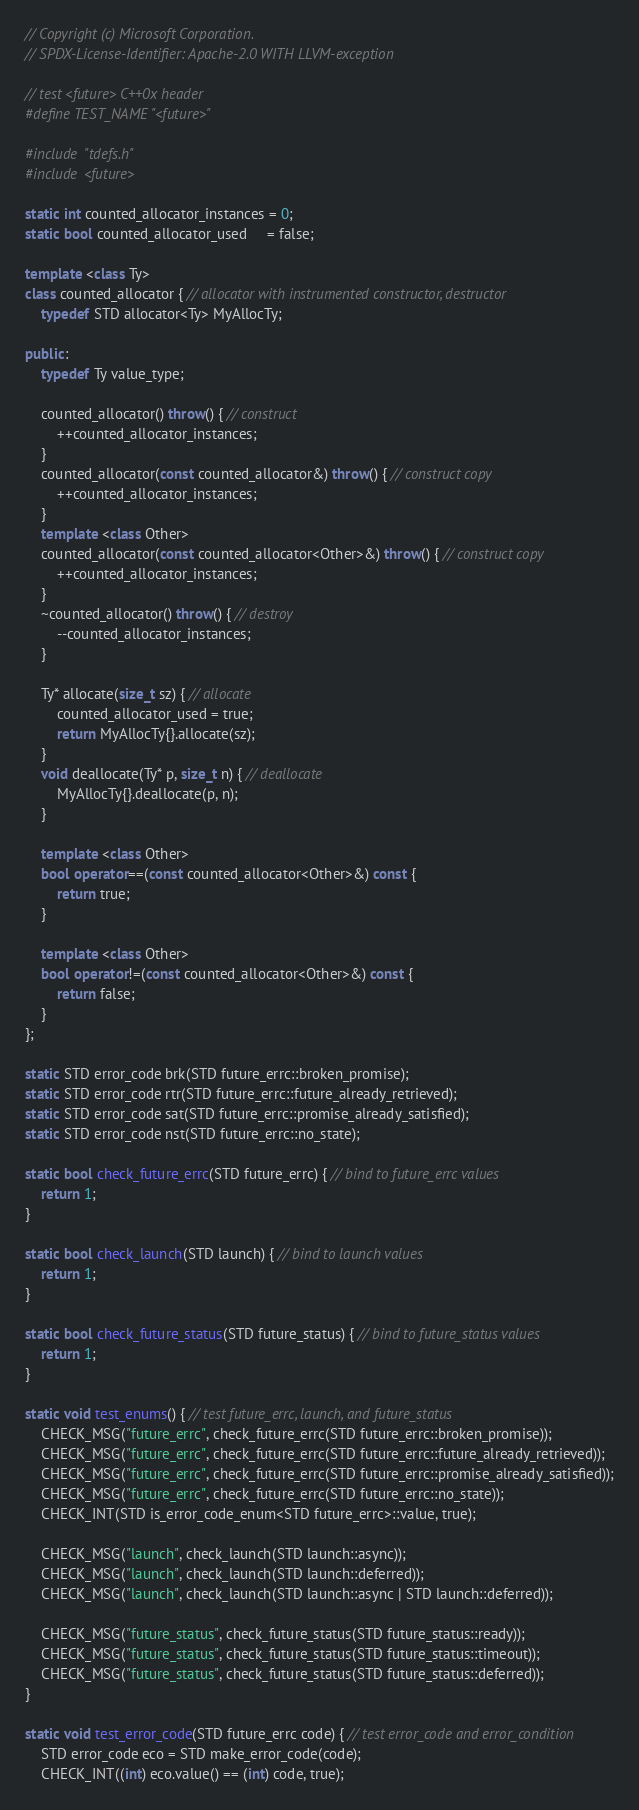Convert code to text. <code><loc_0><loc_0><loc_500><loc_500><_C++_>// Copyright (c) Microsoft Corporation.
// SPDX-License-Identifier: Apache-2.0 WITH LLVM-exception

// test <future> C++0x header
#define TEST_NAME "<future>"

#include "tdefs.h"
#include <future>

static int counted_allocator_instances = 0;
static bool counted_allocator_used     = false;

template <class Ty>
class counted_allocator { // allocator with instrumented constructor, destructor
    typedef STD allocator<Ty> MyAllocTy;

public:
    typedef Ty value_type;

    counted_allocator() throw() { // construct
        ++counted_allocator_instances;
    }
    counted_allocator(const counted_allocator&) throw() { // construct copy
        ++counted_allocator_instances;
    }
    template <class Other>
    counted_allocator(const counted_allocator<Other>&) throw() { // construct copy
        ++counted_allocator_instances;
    }
    ~counted_allocator() throw() { // destroy
        --counted_allocator_instances;
    }

    Ty* allocate(size_t sz) { // allocate
        counted_allocator_used = true;
        return MyAllocTy{}.allocate(sz);
    }
    void deallocate(Ty* p, size_t n) { // deallocate
        MyAllocTy{}.deallocate(p, n);
    }

    template <class Other>
    bool operator==(const counted_allocator<Other>&) const {
        return true;
    }

    template <class Other>
    bool operator!=(const counted_allocator<Other>&) const {
        return false;
    }
};

static STD error_code brk(STD future_errc::broken_promise);
static STD error_code rtr(STD future_errc::future_already_retrieved);
static STD error_code sat(STD future_errc::promise_already_satisfied);
static STD error_code nst(STD future_errc::no_state);

static bool check_future_errc(STD future_errc) { // bind to future_errc values
    return 1;
}

static bool check_launch(STD launch) { // bind to launch values
    return 1;
}

static bool check_future_status(STD future_status) { // bind to future_status values
    return 1;
}

static void test_enums() { // test future_errc, launch, and future_status
    CHECK_MSG("future_errc", check_future_errc(STD future_errc::broken_promise));
    CHECK_MSG("future_errc", check_future_errc(STD future_errc::future_already_retrieved));
    CHECK_MSG("future_errc", check_future_errc(STD future_errc::promise_already_satisfied));
    CHECK_MSG("future_errc", check_future_errc(STD future_errc::no_state));
    CHECK_INT(STD is_error_code_enum<STD future_errc>::value, true);

    CHECK_MSG("launch", check_launch(STD launch::async));
    CHECK_MSG("launch", check_launch(STD launch::deferred));
    CHECK_MSG("launch", check_launch(STD launch::async | STD launch::deferred));

    CHECK_MSG("future_status", check_future_status(STD future_status::ready));
    CHECK_MSG("future_status", check_future_status(STD future_status::timeout));
    CHECK_MSG("future_status", check_future_status(STD future_status::deferred));
}

static void test_error_code(STD future_errc code) { // test error_code and error_condition
    STD error_code eco = STD make_error_code(code);
    CHECK_INT((int) eco.value() == (int) code, true);</code> 